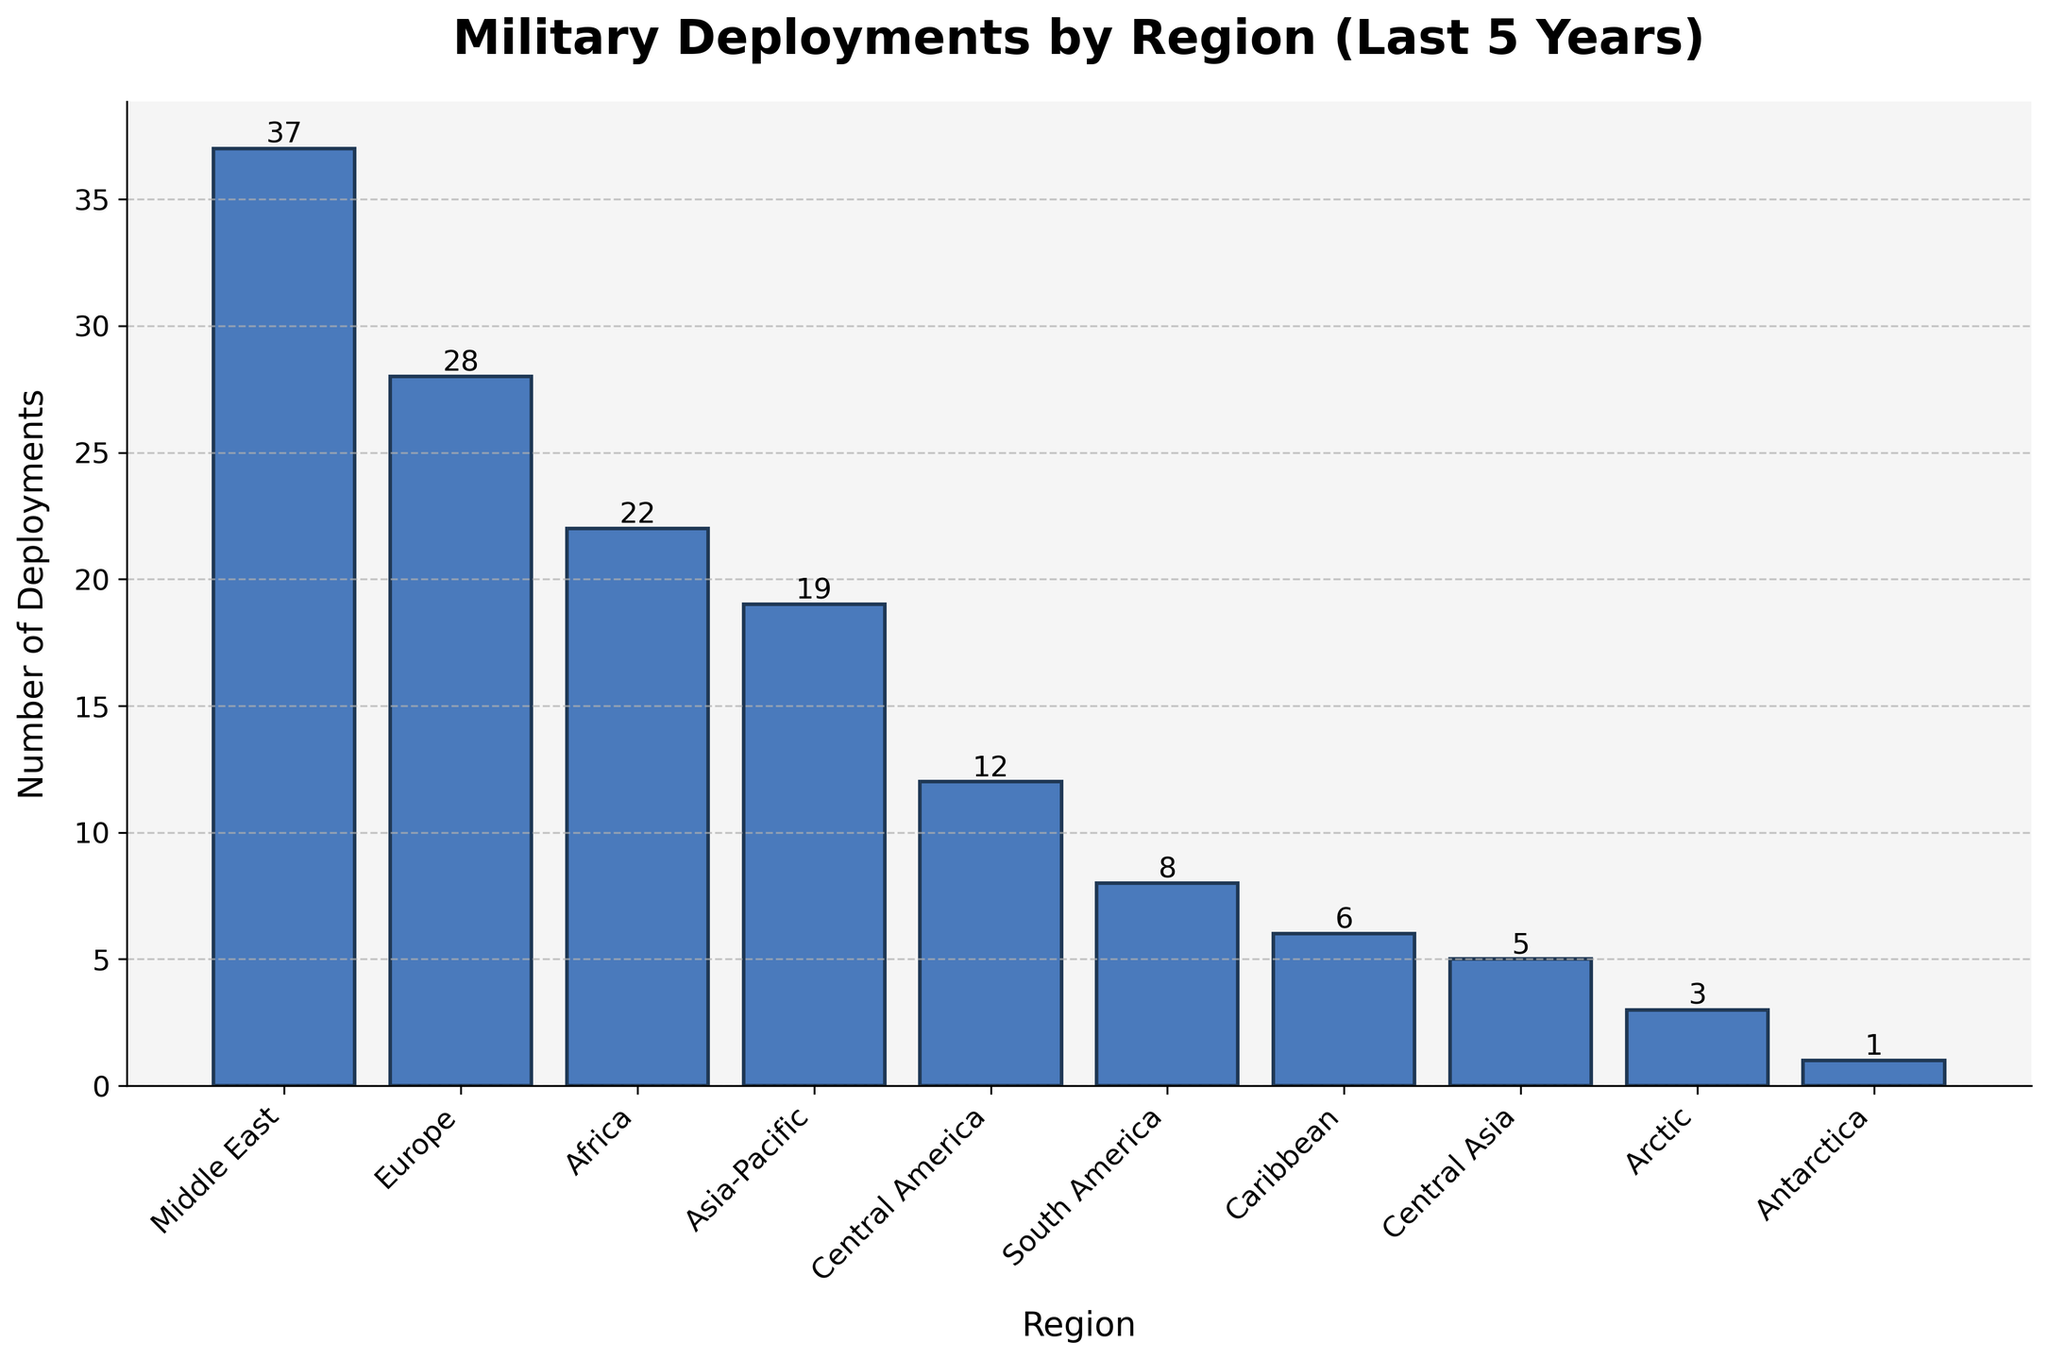Which region had the highest number of deployments? By visually identifying the region with the tallest bar in the chart, we can discern that the Middle East had the highest number of deployments at 37.
Answer: Middle East Which region had the lowest number of deployments? By pinpointing the region with the shortest bar in the chart, we observe that Antarctica had the lowest number of deployments at 1.
Answer: Antarctica What's the difference in deployments between Europe and Asia-Pacific? From the chart, Europe had 28 deployments and Asia-Pacific had 19 deployments. The difference is 28 - 19 = 9.
Answer: 9 How many total deployments were made to Africa, Central America, and South America combined? Summing the deployments for these regions: Africa (22) + Central America (12) + South America (8) = 42.
Answer: 42 Which two regions have the closest number of deployments? By comparing the heights of the bars, Central Asia (5) and the Arctic (3) have the closest numbers with a difference of only 2.
Answer: Central Asia and Arctic What is the average number of deployments across all regions? Adding the deployments for all regions: 37 + 28 + 22 + 19 + 12 + 8 + 6 + 5 + 3 + 1 = 141. There are 10 regions, so the average is 141 / 10 = 14.1.
Answer: 14.1 Are there more deployments in Europe or Africa? By how much? From the chart, Europe had 28 deployments and Africa had 22. Europe has 28 - 22 = 6 more deployments than Africa.
Answer: Europe by 6 What proportion of the total deployments were made to the Caribbean? The total deployments are 141. For the Caribbean, the number is 6. The proportion is 6 / 141 ≈ 0.0426 or 4.26%.
Answer: 4.26% Which regions had fewer than 10 deployments? From the chart, the regions with fewer than 10 deployments are South America (8), Caribbean (6), Central Asia (5), Arctic (3), and Antarctica (1).
Answer: South America, Caribbean, Central Asia, Arctic, Antarctica What is the sum of deployments to the Middle East and Central America? From the chart, the Middle East had 37 deployments and Central America had 12. Their sum is 37 + 12 = 49.
Answer: 49 